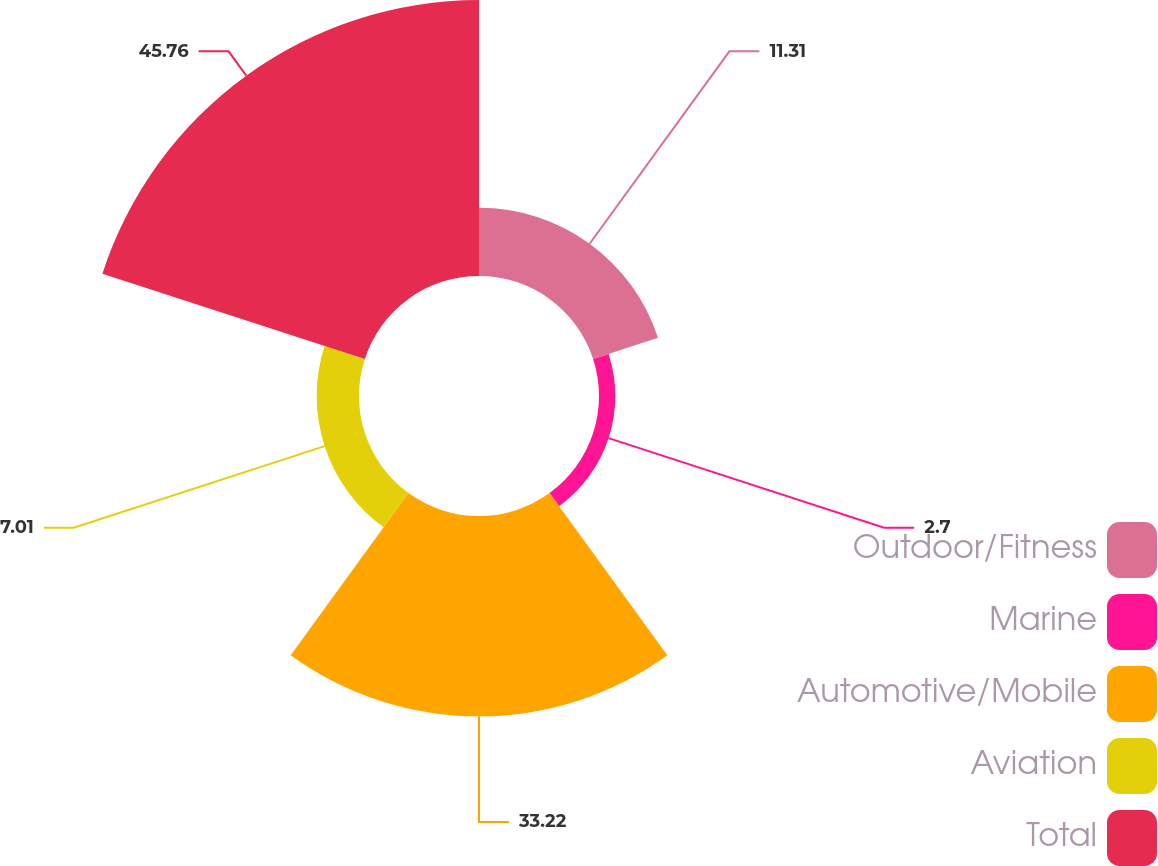<chart> <loc_0><loc_0><loc_500><loc_500><pie_chart><fcel>Outdoor/Fitness<fcel>Marine<fcel>Automotive/Mobile<fcel>Aviation<fcel>Total<nl><fcel>11.31%<fcel>2.7%<fcel>33.22%<fcel>7.01%<fcel>45.76%<nl></chart> 